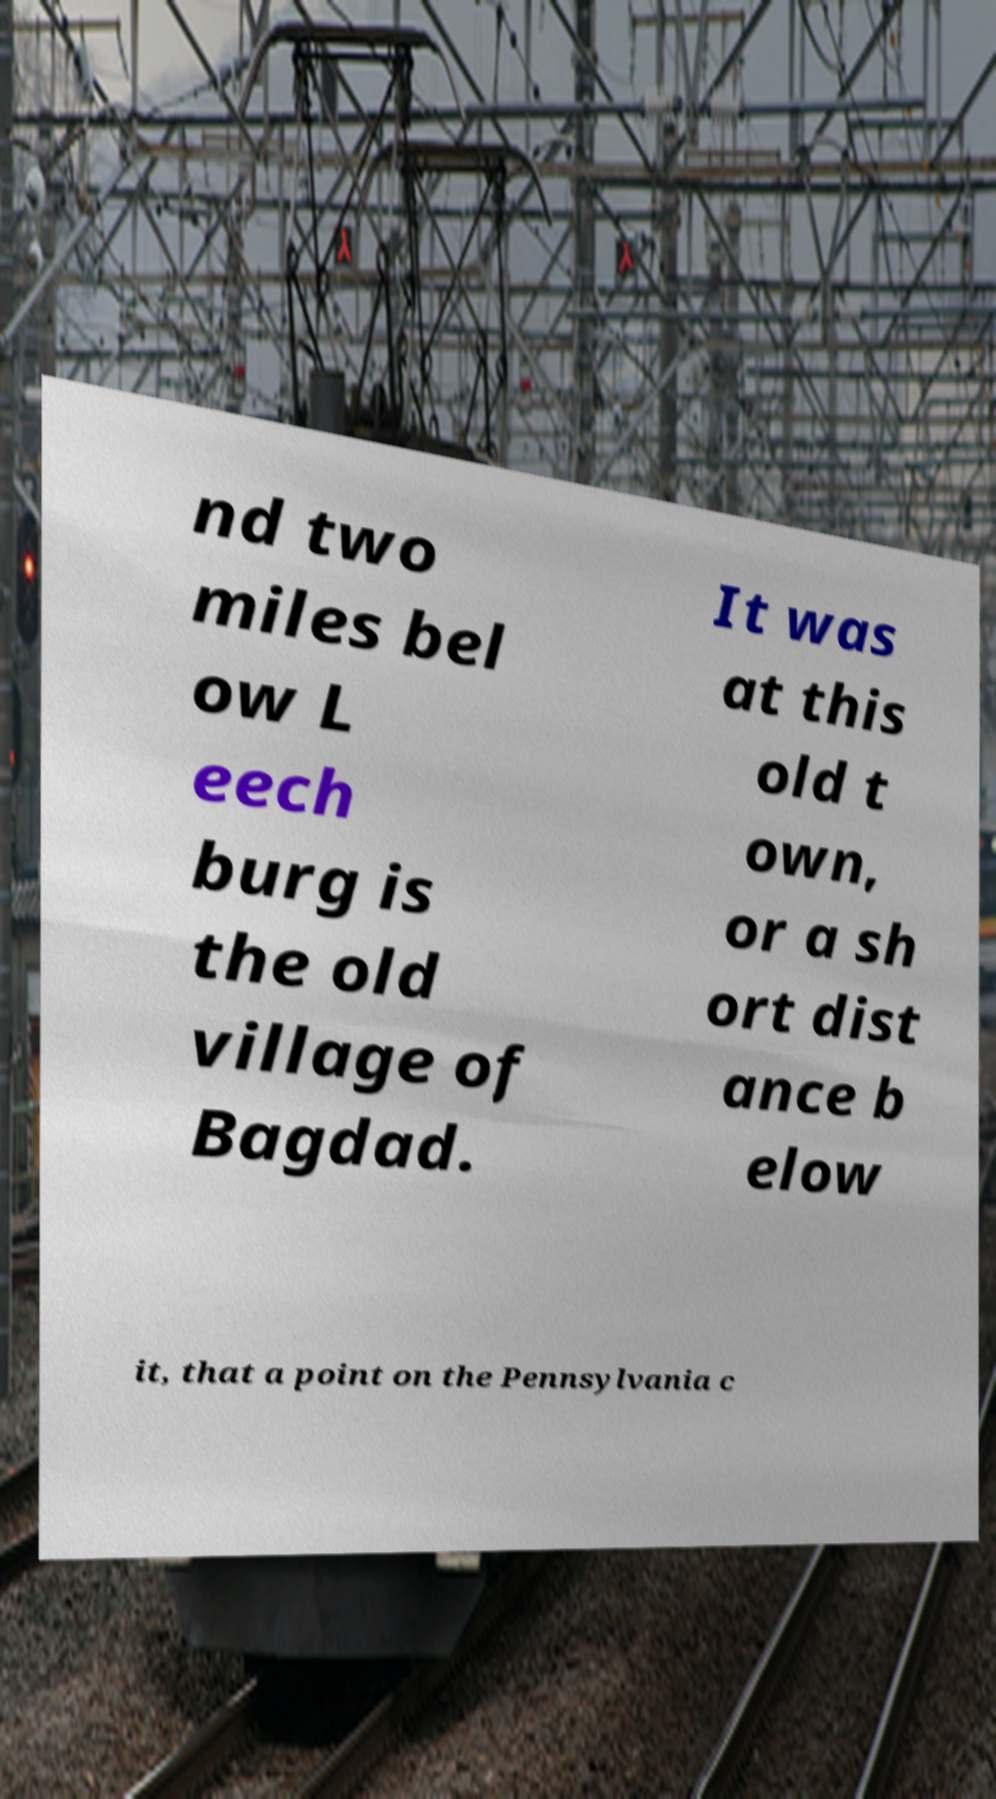Can you accurately transcribe the text from the provided image for me? nd two miles bel ow L eech burg is the old village of Bagdad. It was at this old t own, or a sh ort dist ance b elow it, that a point on the Pennsylvania c 